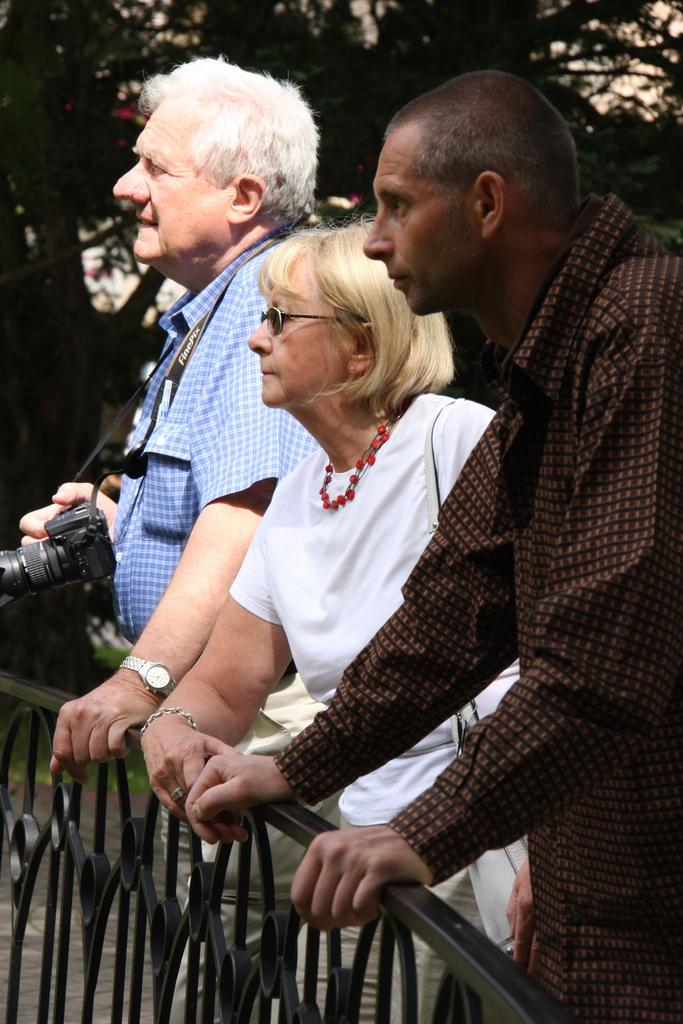How many people are in the image? There are three persons in the image. What are the persons doing in the image? The persons are standing and holding a bridge wall. Can you describe the position of the person on the left side of the image? The person on the left side is holding a camera. What type of tent can be seen in the image? There is no tent present in the image. What is the visibility like in the image due to the mist? There is no mention of mist in the image, so it cannot be determined how visibility is affected. 